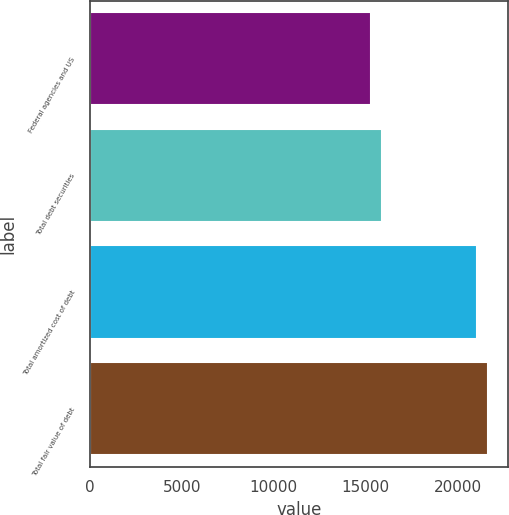Convert chart. <chart><loc_0><loc_0><loc_500><loc_500><bar_chart><fcel>Federal agencies and US<fcel>Total debt securities<fcel>Total amortized cost of debt<fcel>Total fair value of debt<nl><fcel>15310<fcel>15915<fcel>21063<fcel>21662.8<nl></chart> 